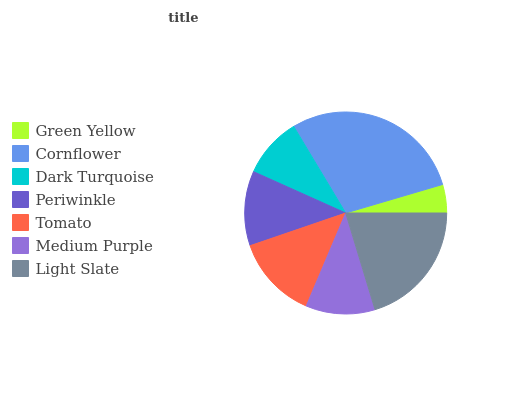Is Green Yellow the minimum?
Answer yes or no. Yes. Is Cornflower the maximum?
Answer yes or no. Yes. Is Dark Turquoise the minimum?
Answer yes or no. No. Is Dark Turquoise the maximum?
Answer yes or no. No. Is Cornflower greater than Dark Turquoise?
Answer yes or no. Yes. Is Dark Turquoise less than Cornflower?
Answer yes or no. Yes. Is Dark Turquoise greater than Cornflower?
Answer yes or no. No. Is Cornflower less than Dark Turquoise?
Answer yes or no. No. Is Periwinkle the high median?
Answer yes or no. Yes. Is Periwinkle the low median?
Answer yes or no. Yes. Is Dark Turquoise the high median?
Answer yes or no. No. Is Medium Purple the low median?
Answer yes or no. No. 